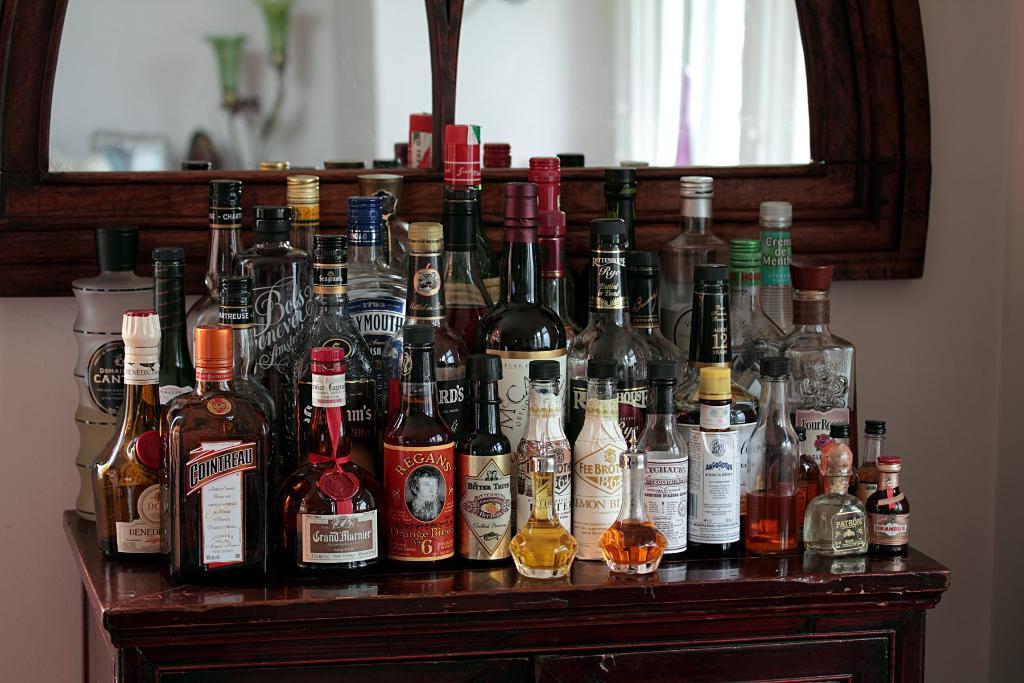What type of tequila is that with the cork top?
Your answer should be very brief. Patron. 